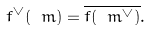Convert formula to latex. <formula><loc_0><loc_0><loc_500><loc_500>f ^ { \vee } ( \ m ) = \overline { f ( \ m ^ { \vee } ) } .</formula> 